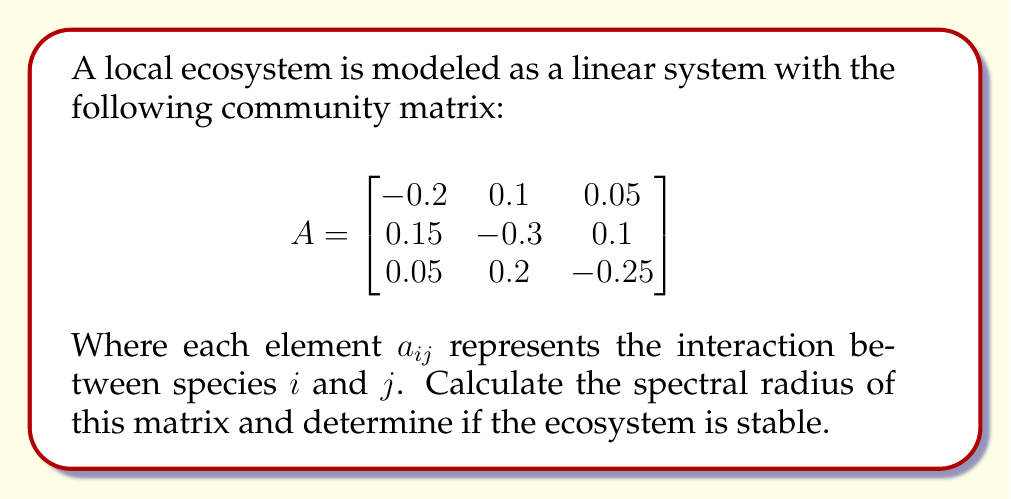Give your solution to this math problem. To analyze the stability of this ecosystem using spectral theory, we need to follow these steps:

1) First, we need to find the eigenvalues of the community matrix $A$. The characteristic equation is:

   $$det(A - \lambda I) = 0$$

2) Expanding this, we get:

   $$(-0.2-\lambda)((-0.3-\lambda)(-0.25-\lambda) - 0.02) - 0.1(0.15(-0.25-\lambda) - 0.005) + 0.05(0.03 - 0.15(-0.3-\lambda)) = 0$$

3) Simplifying:

   $$-\lambda^3 - 0.75\lambda^2 - 0.1825\lambda - 0.01375 = 0$$

4) This cubic equation can be solved numerically. The eigenvalues are approximately:

   $$\lambda_1 \approx -0.5741$$
   $$\lambda_2 \approx -0.0880 + 0.1523i$$
   $$\lambda_3 \approx -0.0880 - 0.1523i$$

5) The spectral radius $\rho(A)$ is the maximum of the absolute values of these eigenvalues:

   $$\rho(A) = \max(|\lambda_1|, |\lambda_2|, |\lambda_3|) \approx 0.5741$$

6) For a linear system $\dot{x} = Ax$, the system is stable if all eigenvalues have negative real parts. In this case, all eigenvalues indeed have negative real parts.

7) Moreover, the spectral radius is less than 1, which indicates that the system will converge to equilibrium over time.

Therefore, based on spectral theory, this ecosystem model is stable.
Answer: The spectral radius is approximately 0.5741, and the ecosystem is stable. 